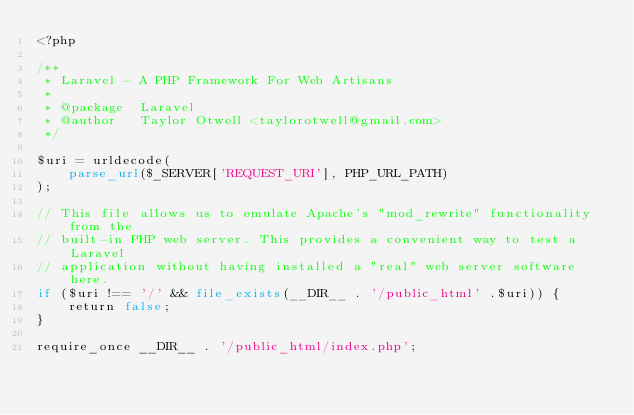Convert code to text. <code><loc_0><loc_0><loc_500><loc_500><_PHP_><?php

/**
 * Laravel - A PHP Framework For Web Artisans
 *
 * @package  Laravel
 * @author   Taylor Otwell <taylorotwell@gmail.com>
 */

$uri = urldecode(
    parse_url($_SERVER['REQUEST_URI'], PHP_URL_PATH)
);

// This file allows us to emulate Apache's "mod_rewrite" functionality from the
// built-in PHP web server. This provides a convenient way to test a Laravel
// application without having installed a "real" web server software here.
if ($uri !== '/' && file_exists(__DIR__ . '/public_html' .$uri)) {
    return false;
}

require_once __DIR__ . '/public_html/index.php';
</code> 